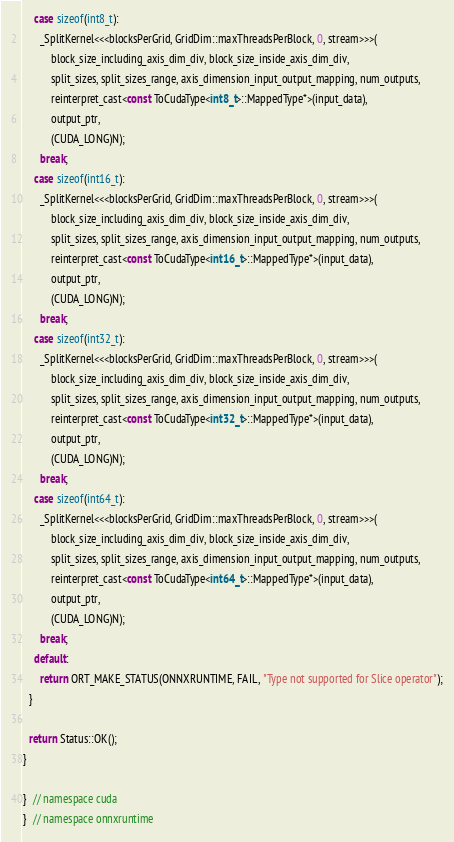Convert code to text. <code><loc_0><loc_0><loc_500><loc_500><_Cuda_>    case sizeof(int8_t):
      _SplitKernel<<<blocksPerGrid, GridDim::maxThreadsPerBlock, 0, stream>>>(
          block_size_including_axis_dim_div, block_size_inside_axis_dim_div,
          split_sizes, split_sizes_range, axis_dimension_input_output_mapping, num_outputs,
          reinterpret_cast<const ToCudaType<int8_t>::MappedType*>(input_data),
          output_ptr,
          (CUDA_LONG)N);
      break;
    case sizeof(int16_t):
      _SplitKernel<<<blocksPerGrid, GridDim::maxThreadsPerBlock, 0, stream>>>(
          block_size_including_axis_dim_div, block_size_inside_axis_dim_div,
          split_sizes, split_sizes_range, axis_dimension_input_output_mapping, num_outputs,
          reinterpret_cast<const ToCudaType<int16_t>::MappedType*>(input_data),
          output_ptr,
          (CUDA_LONG)N);
      break;
    case sizeof(int32_t):
      _SplitKernel<<<blocksPerGrid, GridDim::maxThreadsPerBlock, 0, stream>>>(
          block_size_including_axis_dim_div, block_size_inside_axis_dim_div,
          split_sizes, split_sizes_range, axis_dimension_input_output_mapping, num_outputs,
          reinterpret_cast<const ToCudaType<int32_t>::MappedType*>(input_data),
          output_ptr,
          (CUDA_LONG)N);
      break;
    case sizeof(int64_t):
      _SplitKernel<<<blocksPerGrid, GridDim::maxThreadsPerBlock, 0, stream>>>(
          block_size_including_axis_dim_div, block_size_inside_axis_dim_div,
          split_sizes, split_sizes_range, axis_dimension_input_output_mapping, num_outputs,
          reinterpret_cast<const ToCudaType<int64_t>::MappedType*>(input_data),
          output_ptr,
          (CUDA_LONG)N);
      break;
    default:
      return ORT_MAKE_STATUS(ONNXRUNTIME, FAIL, "Type not supported for Slice operator");
  }

  return Status::OK();
}

}  // namespace cuda
}  // namespace onnxruntime</code> 